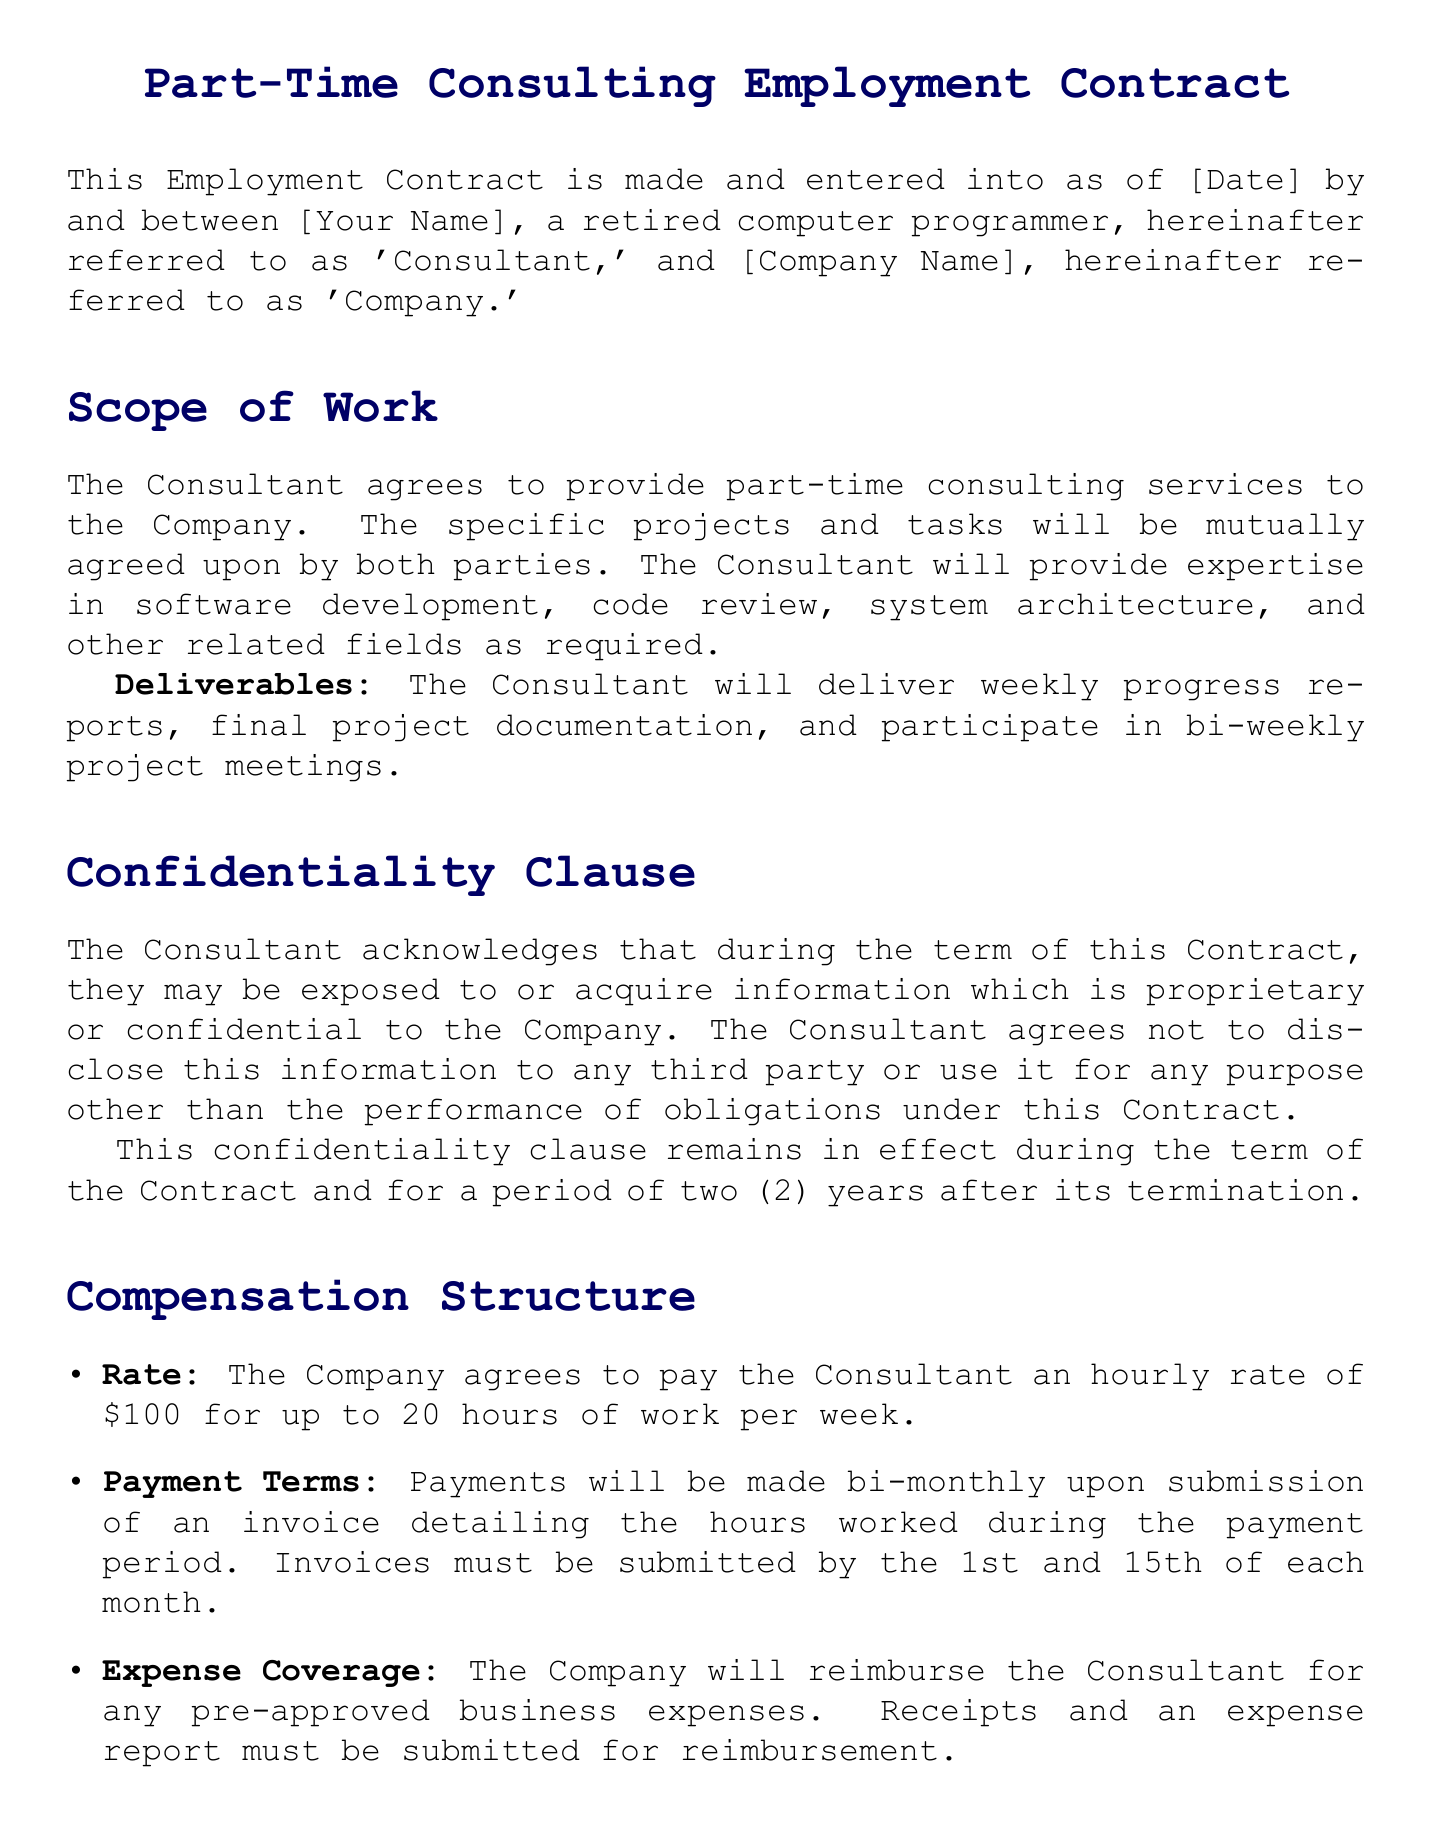What is the Consultant's hourly rate? The Consultant's hourly rate is specified in the Compensation Structure section of the document.
Answer: $100 How many hours per week is the Consultant expected to work? The document specifies the maximum number of hours the Consultant can work per week.
Answer: 20 hours What is the term for the confidentiality clause post-termination? The duration of the confidentiality obligation is stated in the Confidentiality Clause.
Answer: two years How often will payments be made? The payment schedule is outlined in the Compensation Structure section of the document.
Answer: bi-monthly What is required from the Consultant for expense reimbursement? The document mentions necessary documentation for expense claims in the Compensation Structure.
Answer: Receipts and an expense report Who must sign the contract for the Company? The document provides a line for a representative of the Company to sign, indicating the need for an authorized individual.
Answer: Representative Name How much advance notice is required for contract termination? The document specifies the notice period for termination in the Termination section.
Answer: 30 days What type of law governs the contract? The governing law is stated in the Miscellaneous section of the document.
Answer: State of [State] What ongoing obligations does the Consultant have during the contract? The duties of the Consultant are outlined in the Scope of Work section, specifying the deliverables.
Answer: bi-weekly project meetings 